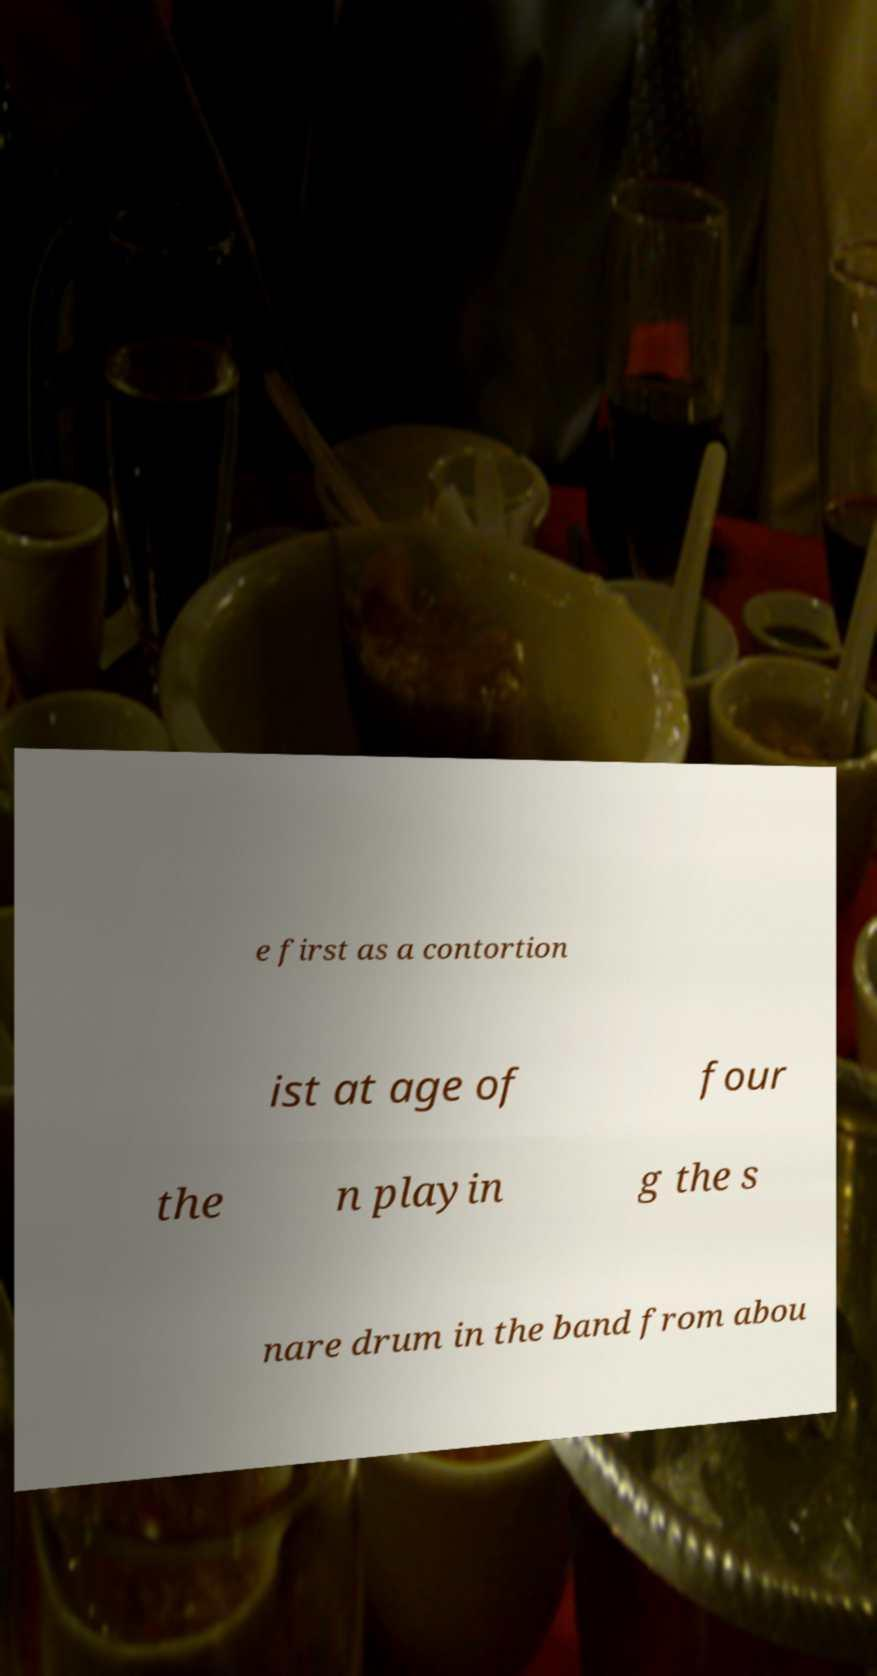Please identify and transcribe the text found in this image. e first as a contortion ist at age of four the n playin g the s nare drum in the band from abou 